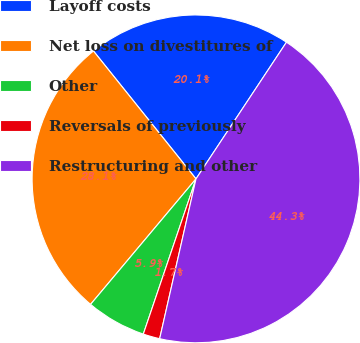<chart> <loc_0><loc_0><loc_500><loc_500><pie_chart><fcel>Layoff costs<fcel>Net loss on divestitures of<fcel>Other<fcel>Reversals of previously<fcel>Restructuring and other<nl><fcel>20.06%<fcel>28.12%<fcel>5.91%<fcel>1.65%<fcel>44.25%<nl></chart> 